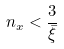<formula> <loc_0><loc_0><loc_500><loc_500>n _ { x } < \frac { 3 } { \bar { \xi } }</formula> 